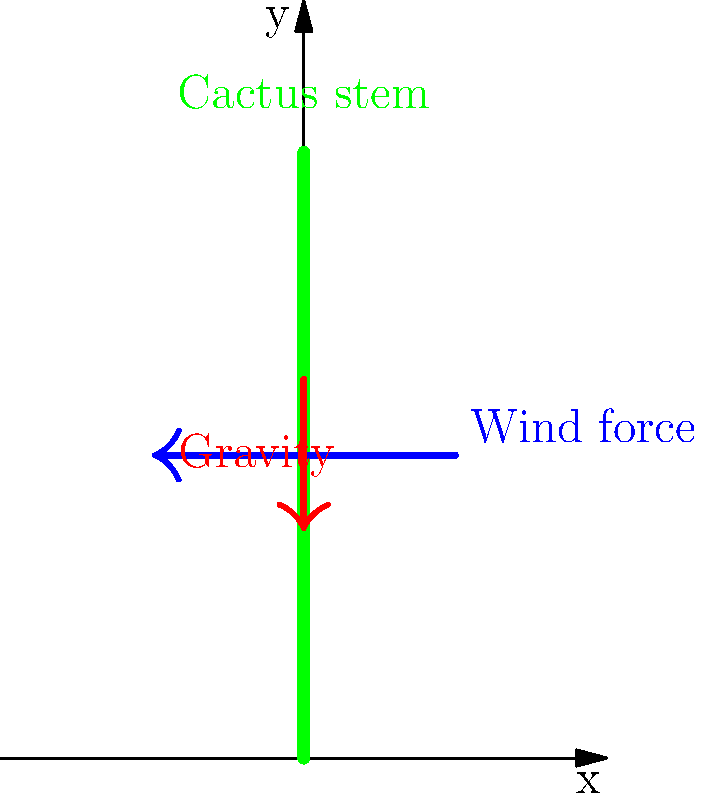Consider a cactus stem in Northern Mexico experiencing strong winds. If the wind exerts a horizontal force of $F_w = 50\text{ N}$ on the stem, and the cactus has a mass of $m = 10\text{ kg}$, what is the magnitude of the resultant force $F_R$ acting on the cactus stem? To find the resultant force, we need to consider the two main forces acting on the cactus stem:

1. Wind force ($F_w$): Horizontal force, given as 50 N.
2. Gravity ($F_g$): Vertical force, calculated as $F_g = mg$, where $g = 9.8\text{ m/s}^2$.

Step 1: Calculate the gravitational force:
$F_g = mg = 10\text{ kg} \times 9.8\text{ m/s}^2 = 98\text{ N}$

Step 2: Use the Pythagorean theorem to calculate the resultant force:
$F_R = \sqrt{F_w^2 + F_g^2}$

Step 3: Substitute the values:
$F_R = \sqrt{(50\text{ N})^2 + (98\text{ N})^2}$

Step 4: Calculate the result:
$F_R = \sqrt{2500 + 9604} = \sqrt{12104} \approx 110.02\text{ N}$

Therefore, the magnitude of the resultant force acting on the cactus stem is approximately 110.02 N.
Answer: $110.02\text{ N}$ 